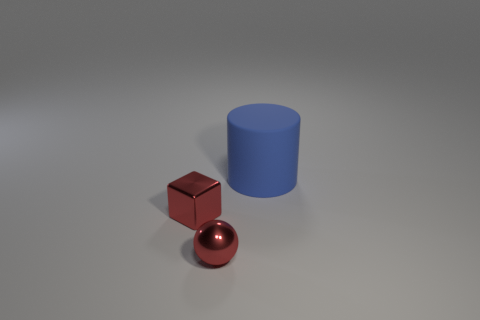Add 2 tiny red metal things. How many objects exist? 5 Subtract all balls. How many objects are left? 2 Add 3 purple rubber cubes. How many purple rubber cubes exist? 3 Subtract 0 gray balls. How many objects are left? 3 Subtract all red things. Subtract all large matte cylinders. How many objects are left? 0 Add 1 blue objects. How many blue objects are left? 2 